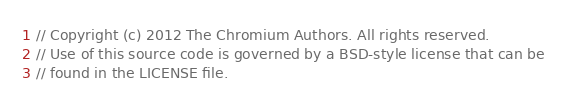Convert code to text. <code><loc_0><loc_0><loc_500><loc_500><_C_>// Copyright (c) 2012 The Chromium Authors. All rights reserved.
// Use of this source code is governed by a BSD-style license that can be
// found in the LICENSE file.
</code> 